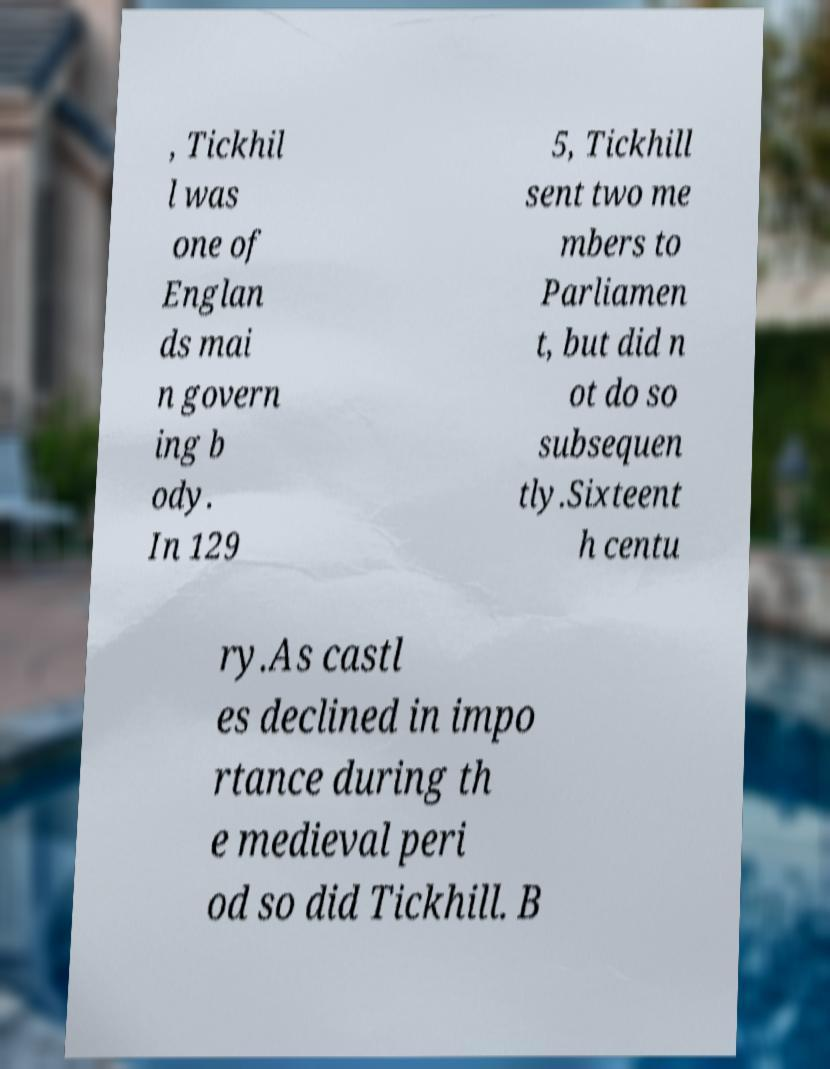Could you extract and type out the text from this image? , Tickhil l was one of Englan ds mai n govern ing b ody. In 129 5, Tickhill sent two me mbers to Parliamen t, but did n ot do so subsequen tly.Sixteent h centu ry.As castl es declined in impo rtance during th e medieval peri od so did Tickhill. B 